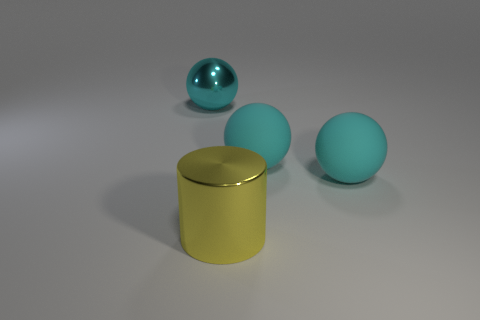The large shiny cylinder has what color?
Give a very brief answer. Yellow. Is the number of big shiny cylinders that are to the right of the cyan metal ball greater than the number of big cyan rubber objects right of the metal cylinder?
Provide a succinct answer. No. There is a shiny thing that is in front of the big cyan shiny object; what is its color?
Ensure brevity in your answer.  Yellow. How many objects are metal cylinders or big cyan metallic objects?
Your response must be concise. 2. What is the material of the cyan ball to the left of the metal thing that is in front of the big cyan metallic ball?
Make the answer very short. Metal. What number of cyan metallic objects have the same shape as the yellow metal thing?
Provide a succinct answer. 0. Are there any other balls of the same color as the metallic sphere?
Provide a succinct answer. Yes. How many things are either big cyan objects in front of the big cyan shiny ball or large cyan balls behind the cylinder?
Make the answer very short. 3. Are there any large yellow metal cylinders behind the cyan sphere left of the yellow cylinder?
Keep it short and to the point. No. There is a cyan shiny thing that is the same size as the shiny cylinder; what shape is it?
Offer a terse response. Sphere. 